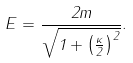<formula> <loc_0><loc_0><loc_500><loc_500>E = \frac { 2 m } { \sqrt { 1 + \left ( \frac { \kappa } { 2 } \right ) ^ { 2 } } } .</formula> 